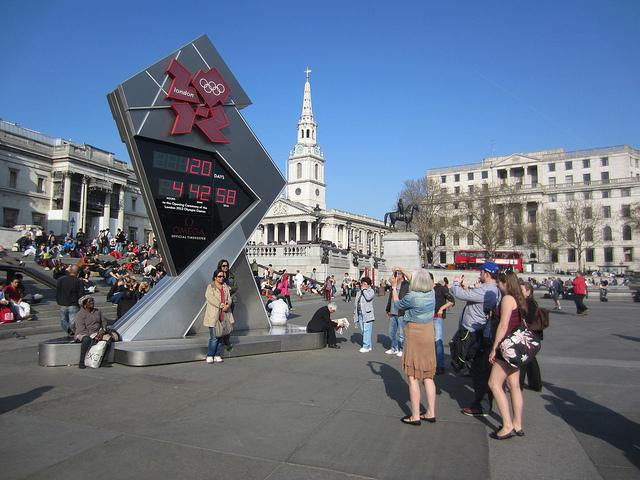What event do the rings signify? Please explain your reasoning. olympics. The particular pattern of overlapping rings visible is commonly known to be associated with answer a. 